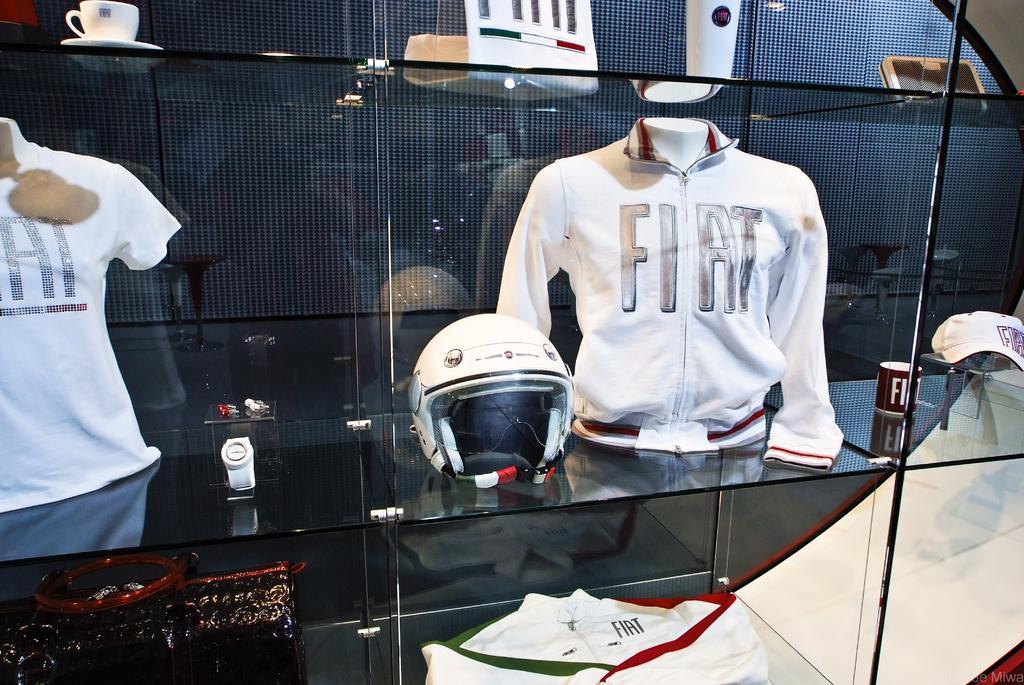Can you describe this image briefly? In this picture I can see the glass rack on which there is a t-shirt, a helmet, a jacket, a cup and a saucer and other few things. 